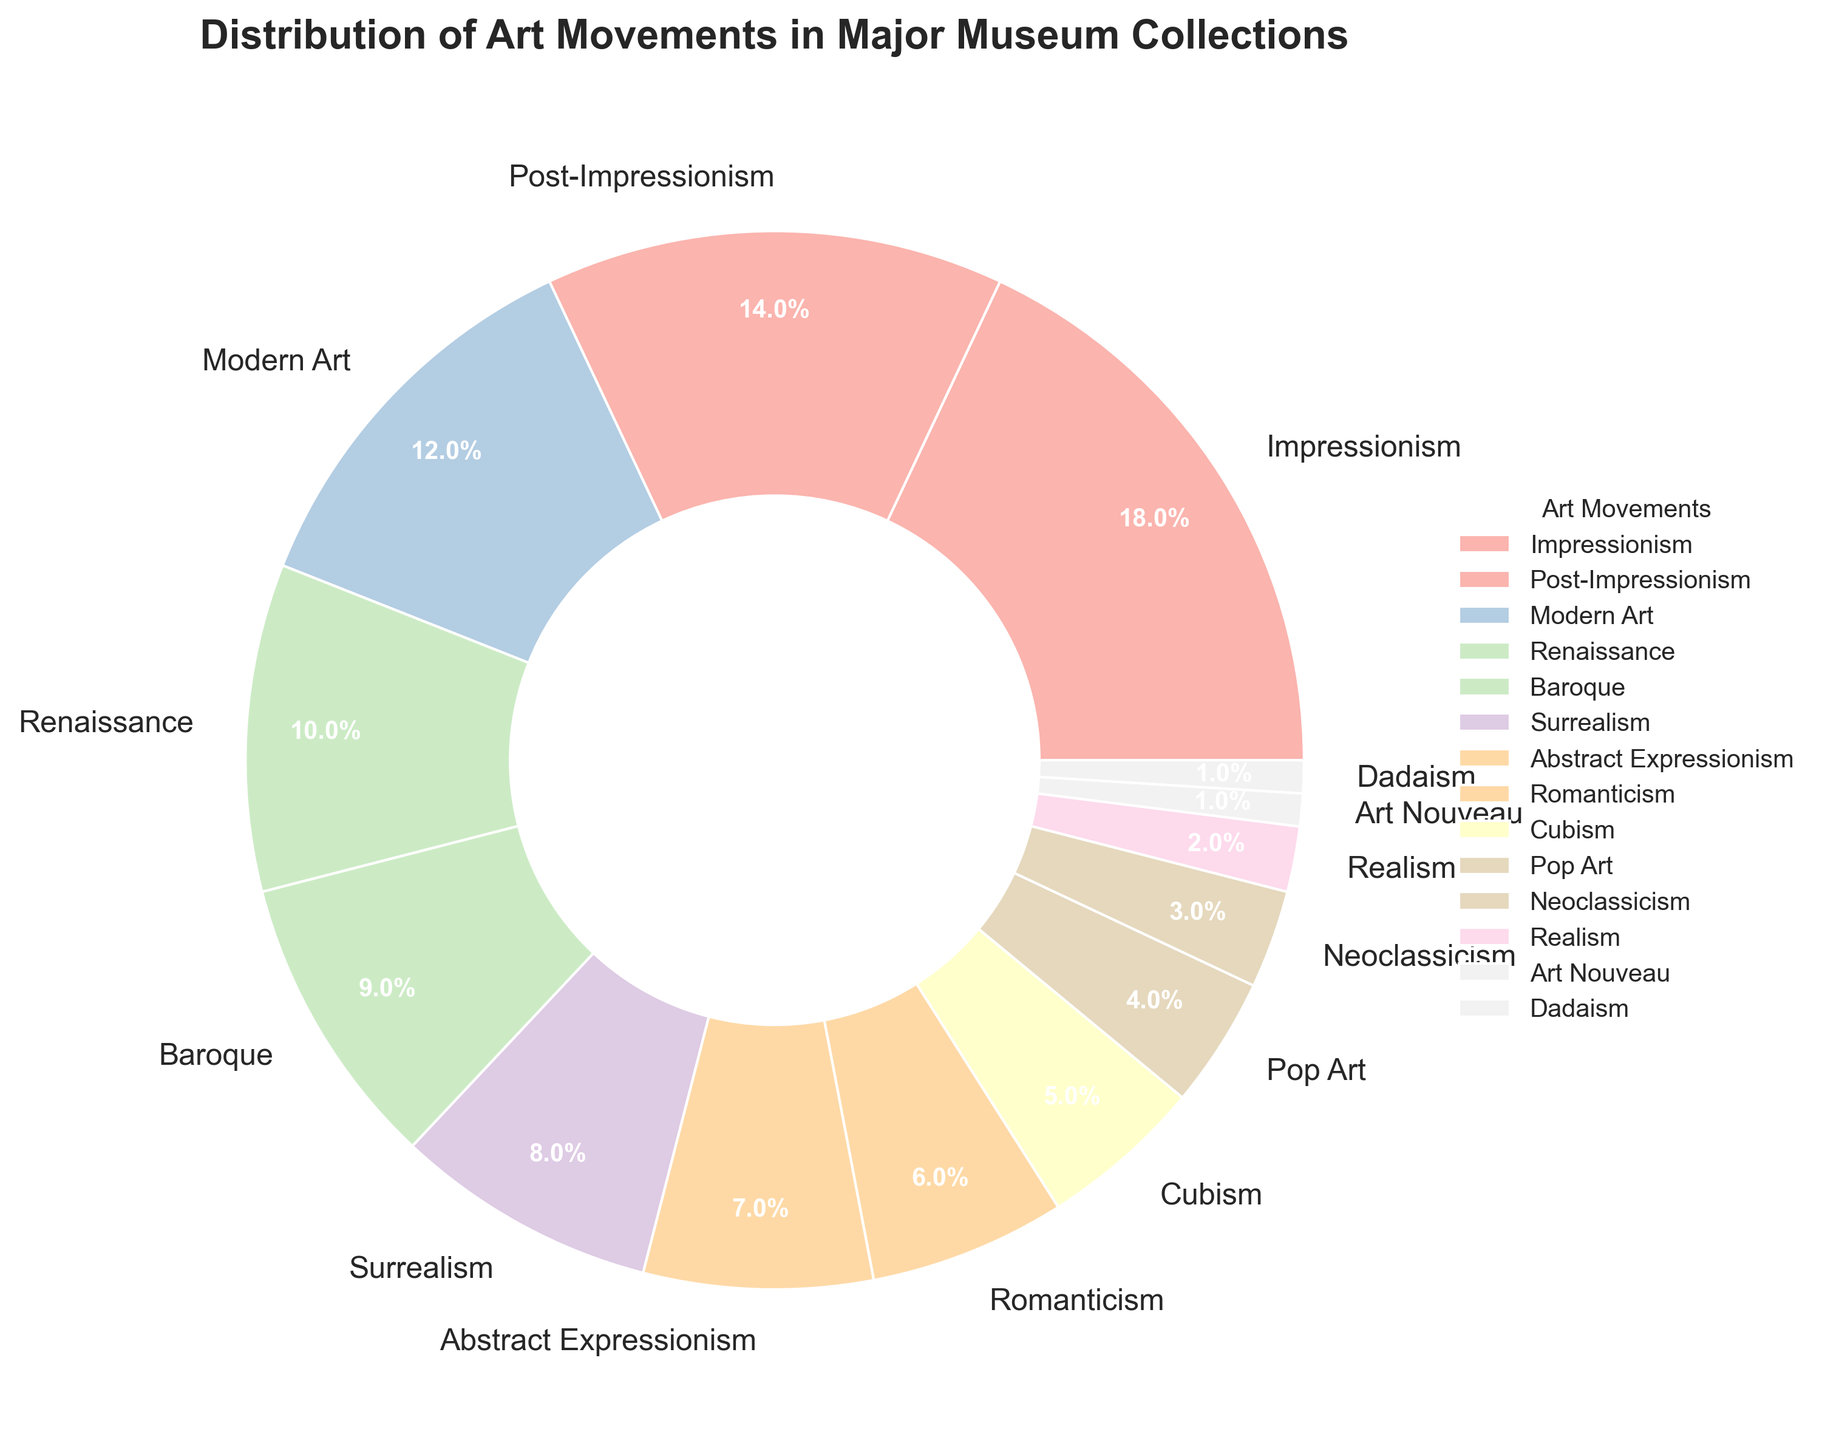Which art movement occupies the largest portion of the pie chart? The largest portion can be identified by finding the segment with the highest percentage. Impressionism has the highest percentage at 18%.
Answer: Impressionism How does the percentage of Modern Art compare to that of Renaissance art? To compare, we look at their respective percentages. Modern Art is 12% and Renaissance is 10%. Modern Art has a slightly higher percentage than Renaissance art.
Answer: Modern Art has a higher percentage than Renaissance art What is the combined percentage of the movements that each have less than 5% representation? Identify the movements with less than 5% and sum their percentages: Pop Art (4), Neoclassicism (3), Realism (2), Art Nouveau (1), and Dadaism (1). Their combined percentage is 4 + 3 + 2 + 1 + 1 = 11%.
Answer: 11% Which art movements have visual segments with warm colors? Colors associated with warm hues (red, yellow, orange) should be identified, and their respective movements can then be inferred. Impressionism (reddish), Baroque (yellow), and Pop Art (orange) have warm colors.
Answer: Impressionism, Baroque, Pop Art What is the difference in percentage between Baroque and Cubism? Subtract the percentage of Cubism from that of Baroque. Baroque is 9%, and Cubism is 5%. The difference is 9 - 5 = 4%.
Answer: 4% If we combine Post-Impressionism and Surrealism, what is their total percentage? Sum the percentages of Post-Impressionism and Surrealism: 14% (Post-Impressionism) + 8% (Surrealism). The combined total is 14 + 8 = 22%.
Answer: 22% Which three art movements have the smallest representation, and what's their total percentage? Identify the movements with the smallest segments: Art Nouveau, Dadaism, and Realism, each with 1%, 1%, and 2% respectively. Sum these percentages: 1 + 1 + 2 = 4%.
Answer: Art Nouveau, Dadaism, Realism; 4% How does the representation of Romanticism compare to Neoclassicism? Compare their percentages: Romanticism is 6%, and Neoclassicism is 3%. Romanticism has twice the representation as Neoclassicism.
Answer: Romanticism is twice Neoclassicism Count the number of movements with a percentage exactly at or above 10%. List the movements and count: Impressionism (18), Post-Impressionism (14), Modern Art (12), and Renaissance (10). There are four movements.
Answer: 4 What is the average percentage of Realism, Romanticism, and Cubism? Sum their percentages (2 for Realism, 6 for Romanticism, and 5 for Cubism) and divide by 3: (2 + 6 + 5) / 3 = 13 / 3 ≈ 4.33%.
Answer: 4.33% 